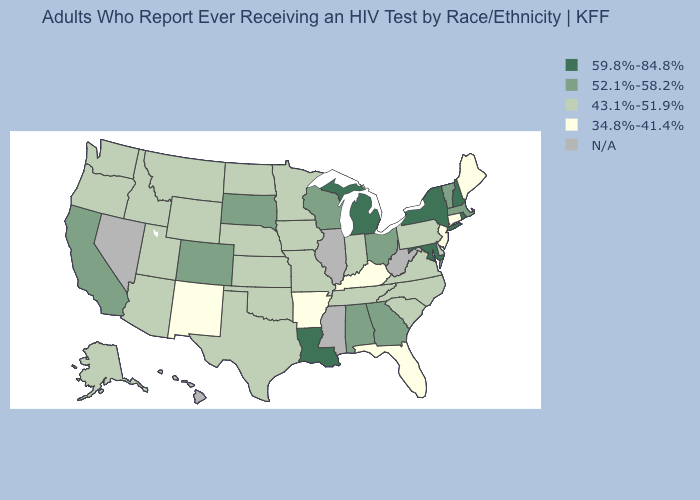Name the states that have a value in the range 59.8%-84.8%?
Answer briefly. Louisiana, Maryland, Michigan, New Hampshire, New York, Rhode Island. Which states have the lowest value in the USA?
Quick response, please. Arkansas, Connecticut, Florida, Kentucky, Maine, New Jersey, New Mexico. Does the map have missing data?
Write a very short answer. Yes. Does the map have missing data?
Write a very short answer. Yes. Name the states that have a value in the range 34.8%-41.4%?
Short answer required. Arkansas, Connecticut, Florida, Kentucky, Maine, New Jersey, New Mexico. Among the states that border North Dakota , does Minnesota have the lowest value?
Short answer required. Yes. Name the states that have a value in the range N/A?
Short answer required. Hawaii, Illinois, Mississippi, Nevada, West Virginia. Is the legend a continuous bar?
Be succinct. No. What is the value of Virginia?
Concise answer only. 43.1%-51.9%. Among the states that border Nevada , which have the highest value?
Keep it brief. California. What is the lowest value in the USA?
Keep it brief. 34.8%-41.4%. Name the states that have a value in the range N/A?
Write a very short answer. Hawaii, Illinois, Mississippi, Nevada, West Virginia. Does the map have missing data?
Short answer required. Yes. What is the value of North Dakota?
Answer briefly. 43.1%-51.9%. 